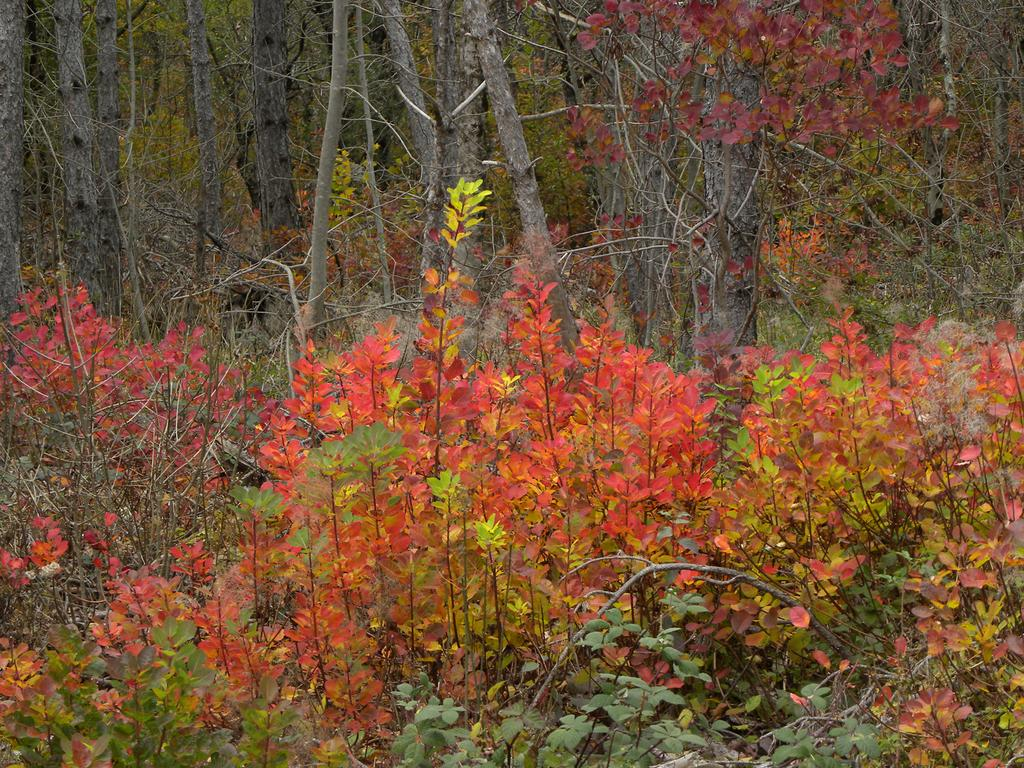What types of vegetation can be seen in the foreground of the image? There are plants and trees in the foreground of the image. Can you describe the specific plants and trees visible in the image? Unfortunately, the facts provided do not give specific details about the plants and trees in the image. What type of acoustics can be heard from the volcano in the image? There is no volcano present in the image, so it is not possible to determine the acoustics from a volcano. 